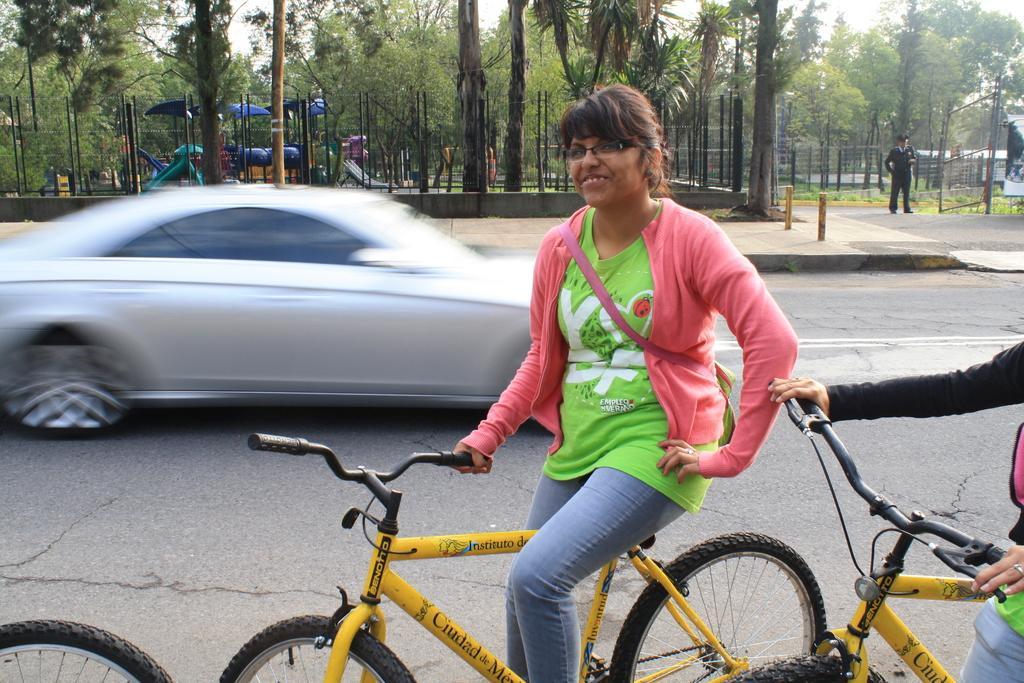How would you summarize this image in a sentence or two? In this image i can see a girl riding bicycle and at the background of the image there is a car which is running and trees,fencing and a policeman at the right side of the image. 